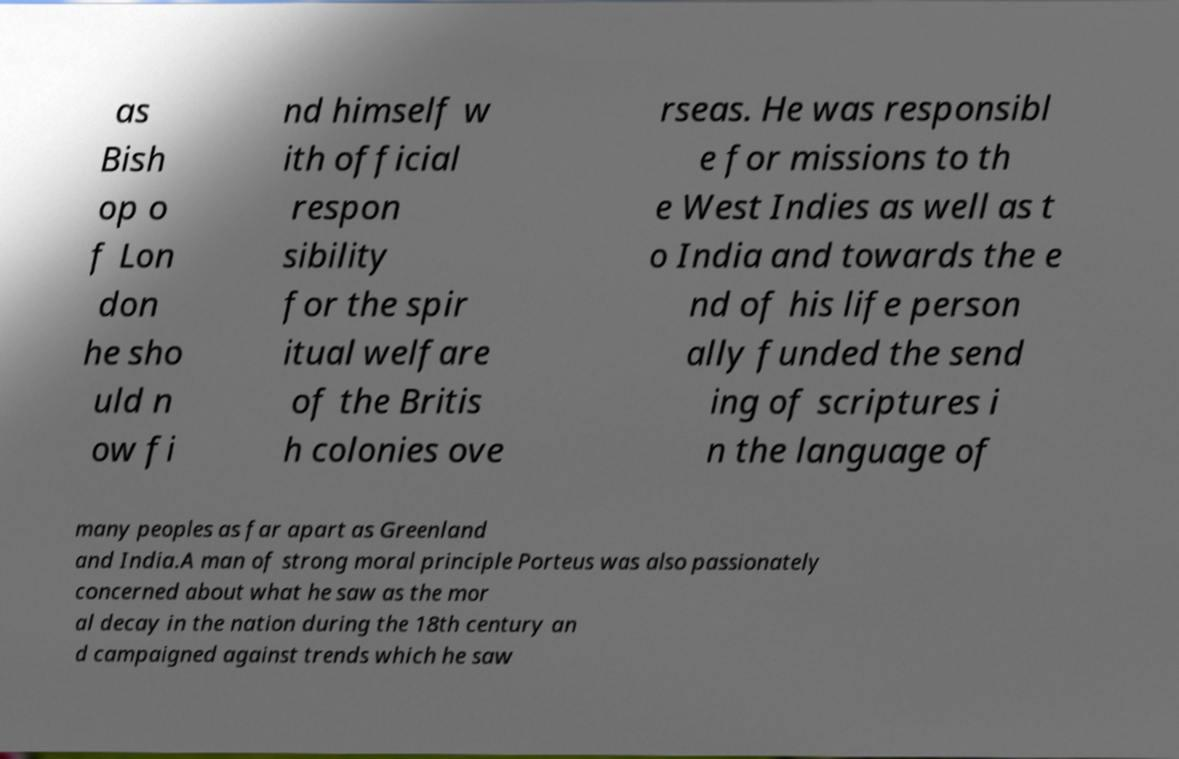Could you assist in decoding the text presented in this image and type it out clearly? as Bish op o f Lon don he sho uld n ow fi nd himself w ith official respon sibility for the spir itual welfare of the Britis h colonies ove rseas. He was responsibl e for missions to th e West Indies as well as t o India and towards the e nd of his life person ally funded the send ing of scriptures i n the language of many peoples as far apart as Greenland and India.A man of strong moral principle Porteus was also passionately concerned about what he saw as the mor al decay in the nation during the 18th century an d campaigned against trends which he saw 